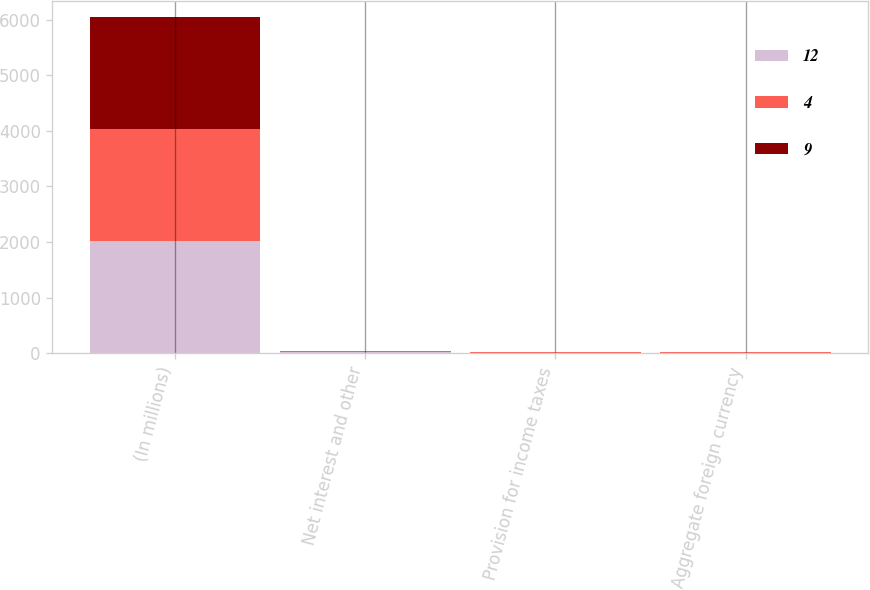Convert chart. <chart><loc_0><loc_0><loc_500><loc_500><stacked_bar_chart><ecel><fcel>(In millions)<fcel>Net interest and other<fcel>Provision for income taxes<fcel>Aggregate foreign currency<nl><fcel>12<fcel>2014<fcel>21<fcel>12<fcel>9<nl><fcel>4<fcel>2013<fcel>14<fcel>2<fcel>12<nl><fcel>9<fcel>2012<fcel>2<fcel>2<fcel>4<nl></chart> 